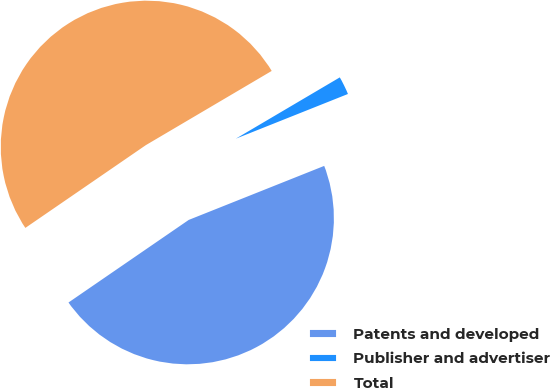Convert chart. <chart><loc_0><loc_0><loc_500><loc_500><pie_chart><fcel>Patents and developed<fcel>Publisher and advertiser<fcel>Total<nl><fcel>46.46%<fcel>2.44%<fcel>51.1%<nl></chart> 